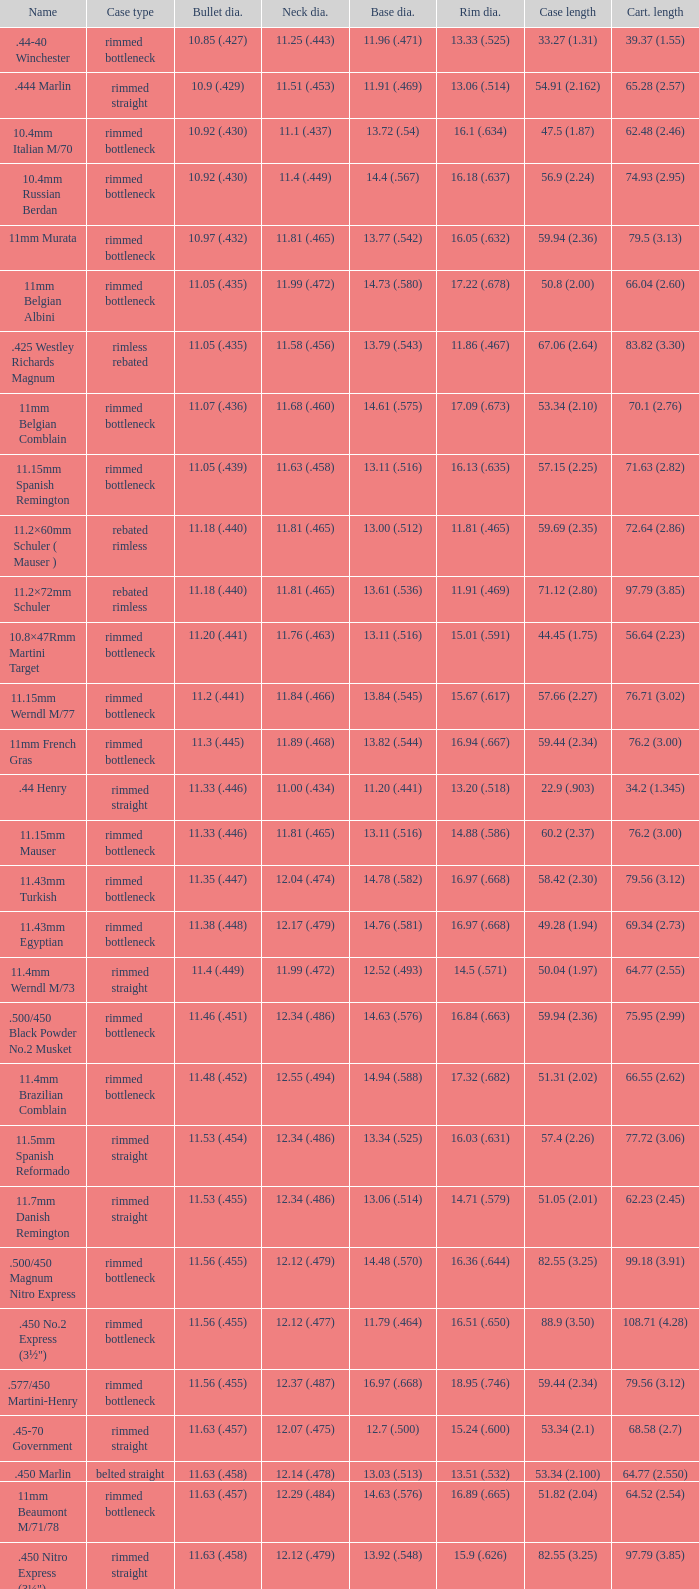Which Bullet diameter has a Name of 11.4mm werndl m/73? 11.4 (.449). 